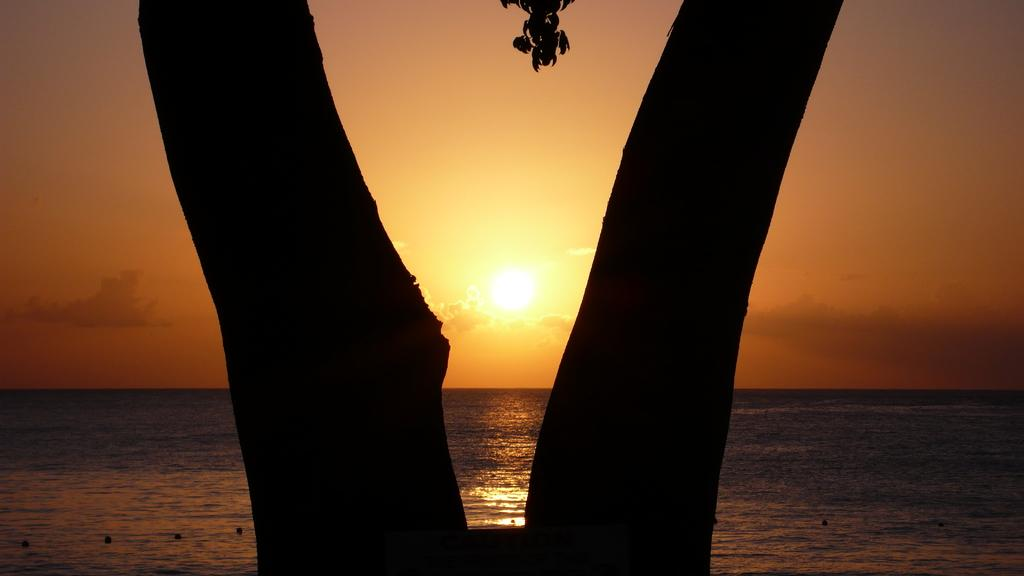What is the main subject in the middle of the image? There is a tree in the middle of the image. What can be seen behind the tree? There is water visible behind the tree. What is visible in the sky in the image? There are clouds in the sky, and the sky is visible in the image. Can the sun be seen in the image? Yes, the sun is observable in the sky. What type of relation can be seen between the tree and the seashore in the image? There is no seashore present in the image; it features a tree, water, clouds, and the sky. 